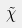Convert formula to latex. <formula><loc_0><loc_0><loc_500><loc_500>\tilde { \chi }</formula> 